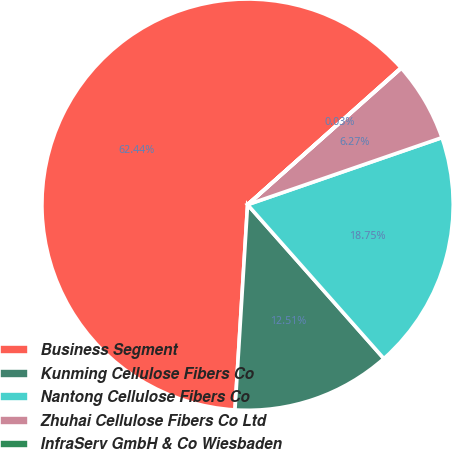Convert chart. <chart><loc_0><loc_0><loc_500><loc_500><pie_chart><fcel>Business Segment<fcel>Kunming Cellulose Fibers Co<fcel>Nantong Cellulose Fibers Co<fcel>Zhuhai Cellulose Fibers Co Ltd<fcel>InfraServ GmbH & Co Wiesbaden<nl><fcel>62.43%<fcel>12.51%<fcel>18.75%<fcel>6.27%<fcel>0.03%<nl></chart> 